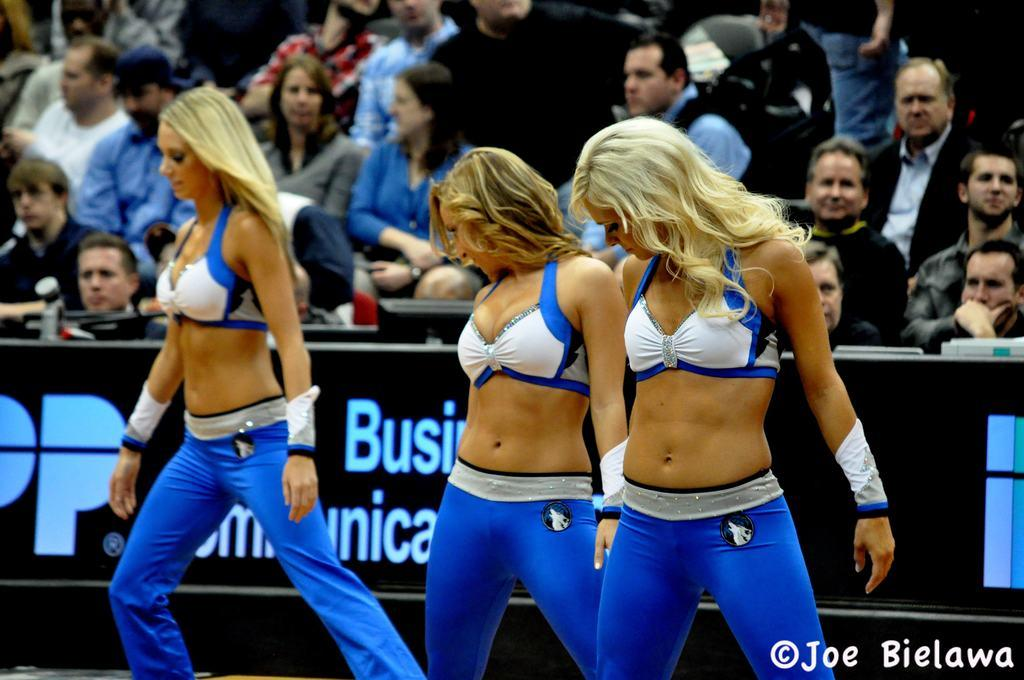<image>
Describe the image concisely. Joe Bielawa snapped a photo of three dances wearing blue and white uniforms 